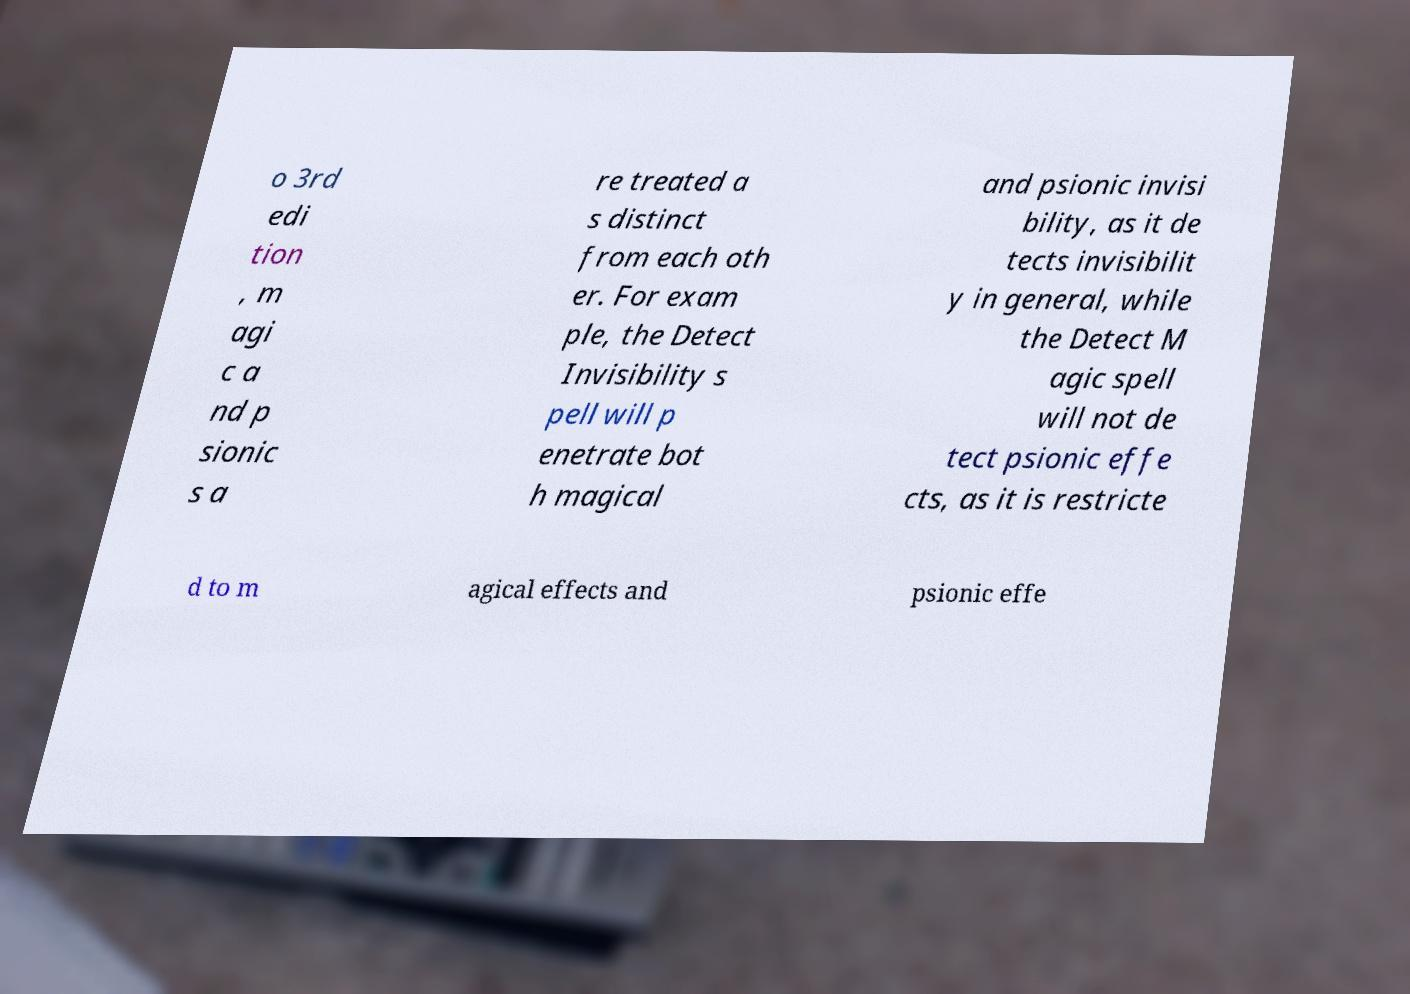I need the written content from this picture converted into text. Can you do that? o 3rd edi tion , m agi c a nd p sionic s a re treated a s distinct from each oth er. For exam ple, the Detect Invisibility s pell will p enetrate bot h magical and psionic invisi bility, as it de tects invisibilit y in general, while the Detect M agic spell will not de tect psionic effe cts, as it is restricte d to m agical effects and psionic effe 